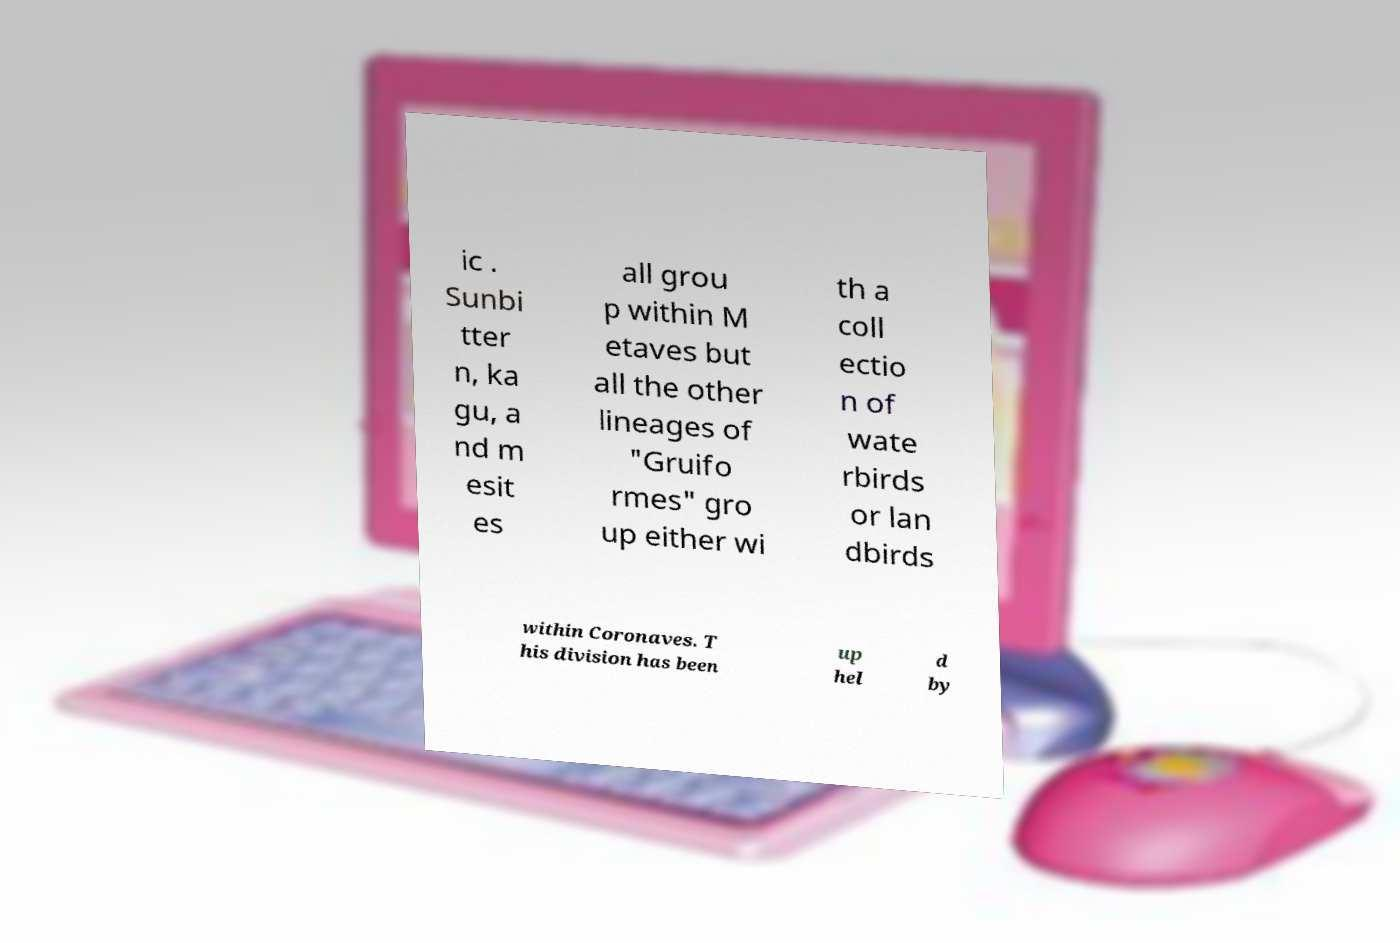Please read and relay the text visible in this image. What does it say? ic . Sunbi tter n, ka gu, a nd m esit es all grou p within M etaves but all the other lineages of "Gruifo rmes" gro up either wi th a coll ectio n of wate rbirds or lan dbirds within Coronaves. T his division has been up hel d by 